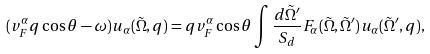Convert formula to latex. <formula><loc_0><loc_0><loc_500><loc_500>( v _ { F } ^ { \alpha } q \cos \theta - \omega ) u _ { \alpha } ( \tilde { \Omega } , q ) = q v _ { F } ^ { \alpha } \cos \theta \int \frac { d \tilde { \Omega } ^ { \prime } } { S _ { d } } F _ { \alpha } ( \tilde { \Omega } , \tilde { \Omega } ^ { \prime } ) u _ { \alpha } ( \tilde { \Omega } ^ { \prime } , q ) ,</formula> 